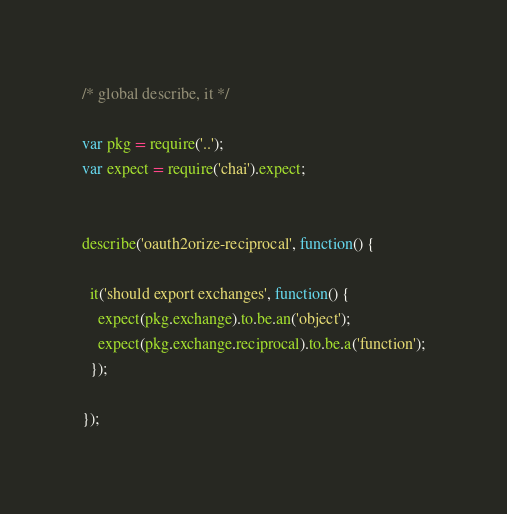<code> <loc_0><loc_0><loc_500><loc_500><_JavaScript_>/* global describe, it */

var pkg = require('..');
var expect = require('chai').expect;


describe('oauth2orize-reciprocal', function() {
  
  it('should export exchanges', function() {
    expect(pkg.exchange).to.be.an('object');
    expect(pkg.exchange.reciprocal).to.be.a('function');
  });
  
});
</code> 